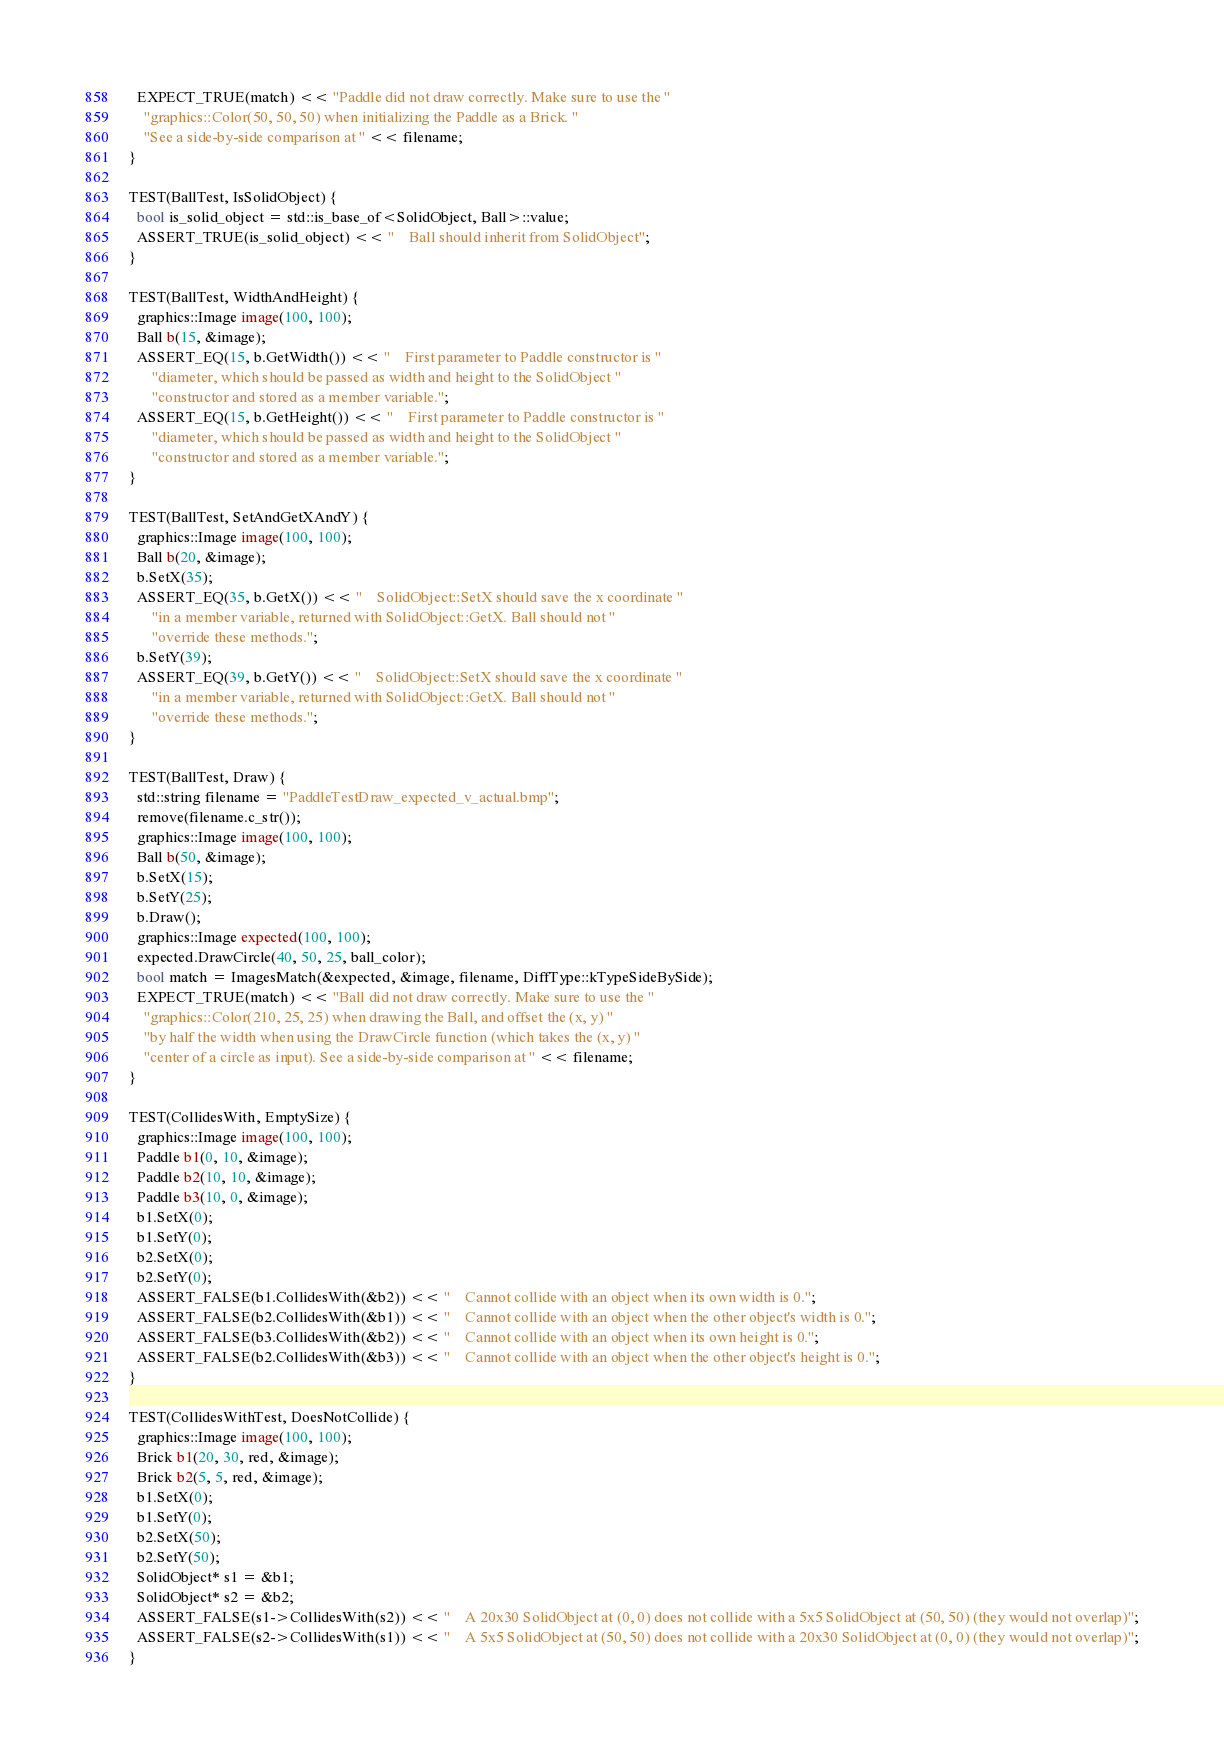Convert code to text. <code><loc_0><loc_0><loc_500><loc_500><_C++_>  EXPECT_TRUE(match) << "Paddle did not draw correctly. Make sure to use the "
    "graphics::Color(50, 50, 50) when initializing the Paddle as a Brick. "
    "See a side-by-side comparison at " << filename;
}

TEST(BallTest, IsSolidObject) {
  bool is_solid_object = std::is_base_of<SolidObject, Ball>::value;
  ASSERT_TRUE(is_solid_object) << "    Ball should inherit from SolidObject";
}

TEST(BallTest, WidthAndHeight) {
  graphics::Image image(100, 100);
  Ball b(15, &image);
  ASSERT_EQ(15, b.GetWidth()) << "    First parameter to Paddle constructor is "
      "diameter, which should be passed as width and height to the SolidObject "
      "constructor and stored as a member variable.";
  ASSERT_EQ(15, b.GetHeight()) << "    First parameter to Paddle constructor is "
      "diameter, which should be passed as width and height to the SolidObject "
      "constructor and stored as a member variable.";
}

TEST(BallTest, SetAndGetXAndY) {
  graphics::Image image(100, 100);
  Ball b(20, &image);
  b.SetX(35);
  ASSERT_EQ(35, b.GetX()) << "    SolidObject::SetX should save the x coordinate "
      "in a member variable, returned with SolidObject::GetX. Ball should not "
      "override these methods.";
  b.SetY(39);
  ASSERT_EQ(39, b.GetY()) << "    SolidObject::SetX should save the x coordinate "
      "in a member variable, returned with SolidObject::GetX. Ball should not "
      "override these methods.";
}

TEST(BallTest, Draw) {
  std::string filename = "PaddleTestDraw_expected_v_actual.bmp";
  remove(filename.c_str());
  graphics::Image image(100, 100);
  Ball b(50, &image);
  b.SetX(15);
  b.SetY(25);
  b.Draw();
  graphics::Image expected(100, 100);
  expected.DrawCircle(40, 50, 25, ball_color);
  bool match = ImagesMatch(&expected, &image, filename, DiffType::kTypeSideBySide);
  EXPECT_TRUE(match) << "Ball did not draw correctly. Make sure to use the "
    "graphics::Color(210, 25, 25) when drawing the Ball, and offset the (x, y) "
    "by half the width when using the DrawCircle function (which takes the (x, y) "
    "center of a circle as input). See a side-by-side comparison at " << filename;
}

TEST(CollidesWith, EmptySize) {
  graphics::Image image(100, 100);
  Paddle b1(0, 10, &image);
  Paddle b2(10, 10, &image);
  Paddle b3(10, 0, &image);
  b1.SetX(0);
  b1.SetY(0);
  b2.SetX(0);
  b2.SetY(0);
  ASSERT_FALSE(b1.CollidesWith(&b2)) << "    Cannot collide with an object when its own width is 0.";
  ASSERT_FALSE(b2.CollidesWith(&b1)) << "    Cannot collide with an object when the other object's width is 0.";
  ASSERT_FALSE(b3.CollidesWith(&b2)) << "    Cannot collide with an object when its own height is 0.";
  ASSERT_FALSE(b2.CollidesWith(&b3)) << "    Cannot collide with an object when the other object's height is 0.";
}

TEST(CollidesWithTest, DoesNotCollide) {
  graphics::Image image(100, 100);
  Brick b1(20, 30, red, &image);
  Brick b2(5, 5, red, &image);
  b1.SetX(0);
  b1.SetY(0);
  b2.SetX(50);
  b2.SetY(50);
  SolidObject* s1 = &b1;
  SolidObject* s2 = &b2;
  ASSERT_FALSE(s1->CollidesWith(s2)) << "    A 20x30 SolidObject at (0, 0) does not collide with a 5x5 SolidObject at (50, 50) (they would not overlap)";
  ASSERT_FALSE(s2->CollidesWith(s1)) << "    A 5x5 SolidObject at (50, 50) does not collide with a 20x30 SolidObject at (0, 0) (they would not overlap)";
}
</code> 